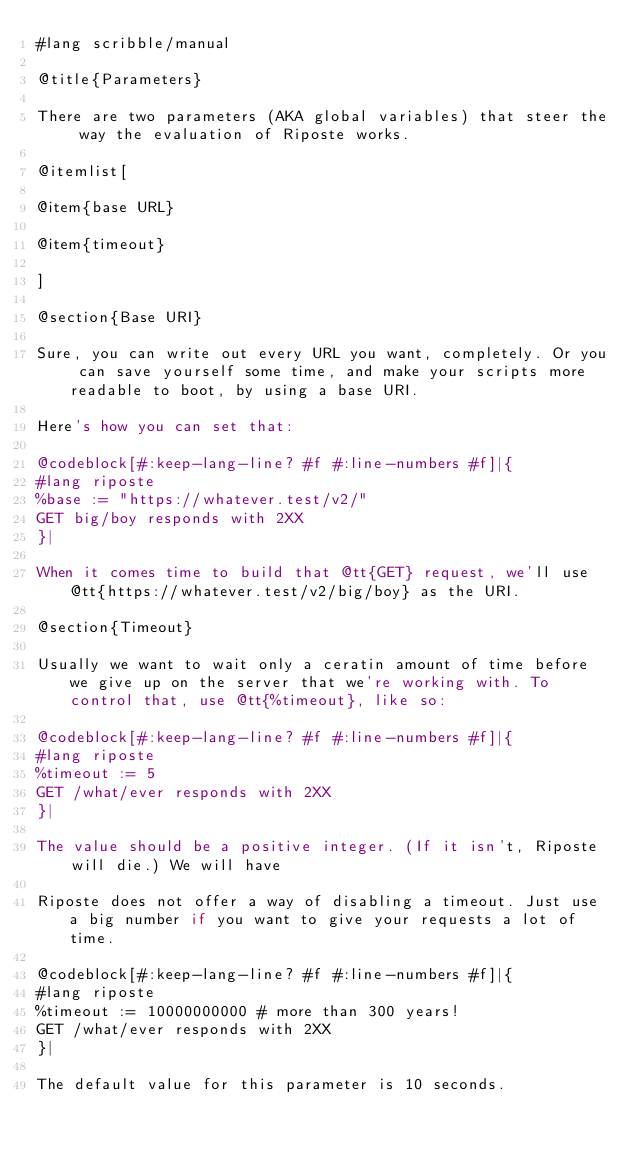Convert code to text. <code><loc_0><loc_0><loc_500><loc_500><_Racket_>#lang scribble/manual

@title{Parameters}

There are two parameters (AKA global variables) that steer the way the evaluation of Riposte works.

@itemlist[

@item{base URL}

@item{timeout}

]

@section{Base URI}

Sure, you can write out every URL you want, completely. Or you can save yourself some time, and make your scripts more readable to boot, by using a base URI.

Here's how you can set that:

@codeblock[#:keep-lang-line? #f #:line-numbers #f]|{
#lang riposte
%base := "https://whatever.test/v2/"
GET big/boy responds with 2XX
}|

When it comes time to build that @tt{GET} request, we'll use @tt{https://whatever.test/v2/big/boy} as the URI.

@section{Timeout}

Usually we want to wait only a ceratin amount of time before we give up on the server that we're working with. To control that, use @tt{%timeout}, like so:

@codeblock[#:keep-lang-line? #f #:line-numbers #f]|{
#lang riposte
%timeout := 5
GET /what/ever responds with 2XX
}|

The value should be a positive integer. (If it isn't, Riposte will die.) We will have

Riposte does not offer a way of disabling a timeout. Just use a big number if you want to give your requests a lot of time.

@codeblock[#:keep-lang-line? #f #:line-numbers #f]|{
#lang riposte
%timeout := 10000000000 # more than 300 years!
GET /what/ever responds with 2XX
}|

The default value for this parameter is 10 seconds.
</code> 